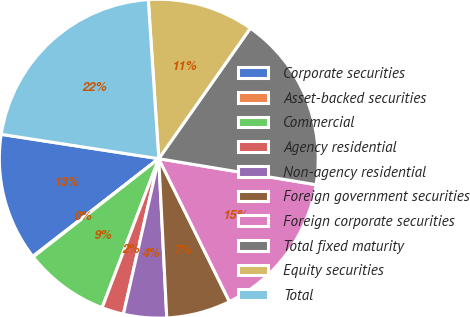Convert chart. <chart><loc_0><loc_0><loc_500><loc_500><pie_chart><fcel>Corporate securities<fcel>Asset-backed securities<fcel>Commercial<fcel>Agency residential<fcel>Non-agency residential<fcel>Foreign government securities<fcel>Foreign corporate securities<fcel>Total fixed maturity<fcel>Equity securities<fcel>Total<nl><fcel>12.94%<fcel>0.07%<fcel>8.65%<fcel>2.22%<fcel>4.36%<fcel>6.51%<fcel>15.08%<fcel>17.87%<fcel>10.79%<fcel>21.51%<nl></chart> 